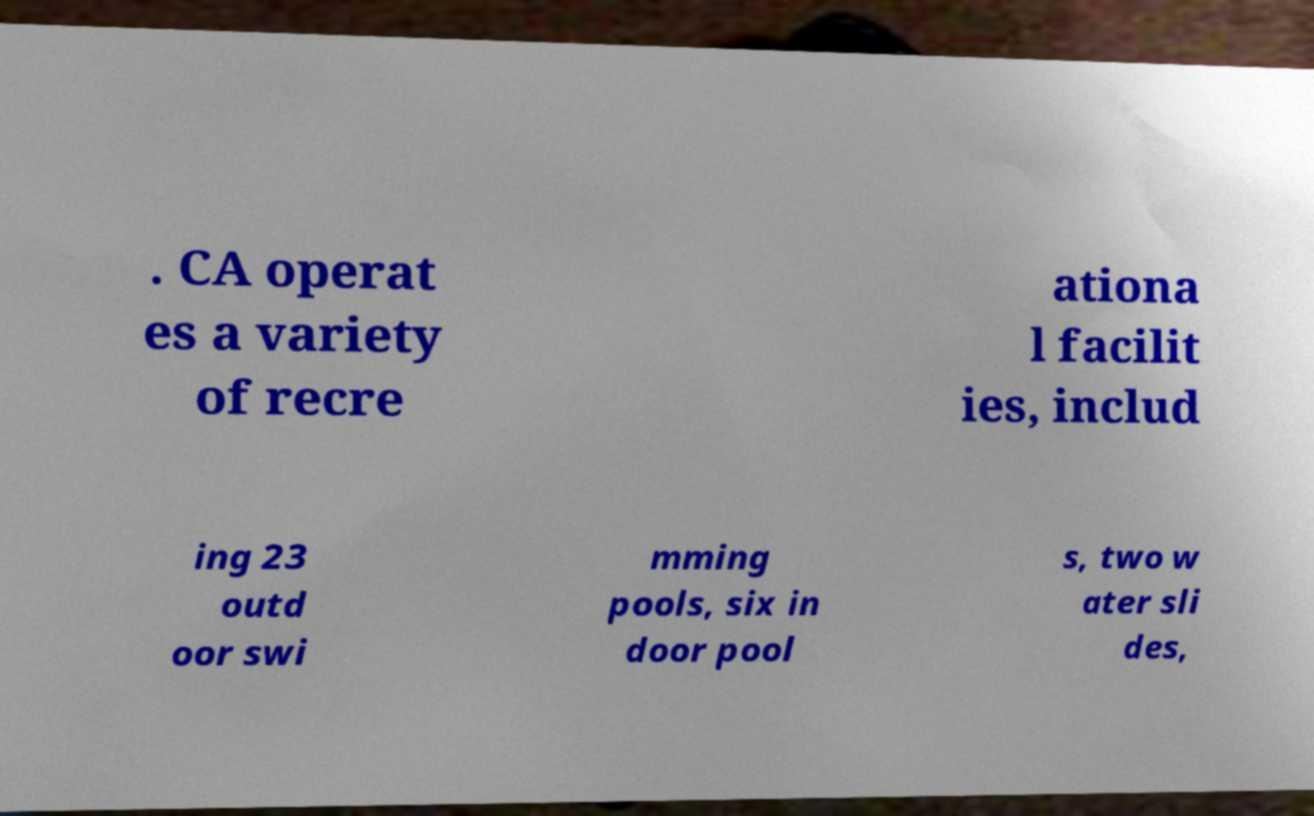Can you accurately transcribe the text from the provided image for me? . CA operat es a variety of recre ationa l facilit ies, includ ing 23 outd oor swi mming pools, six in door pool s, two w ater sli des, 